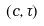<formula> <loc_0><loc_0><loc_500><loc_500>( c , \tau )</formula> 